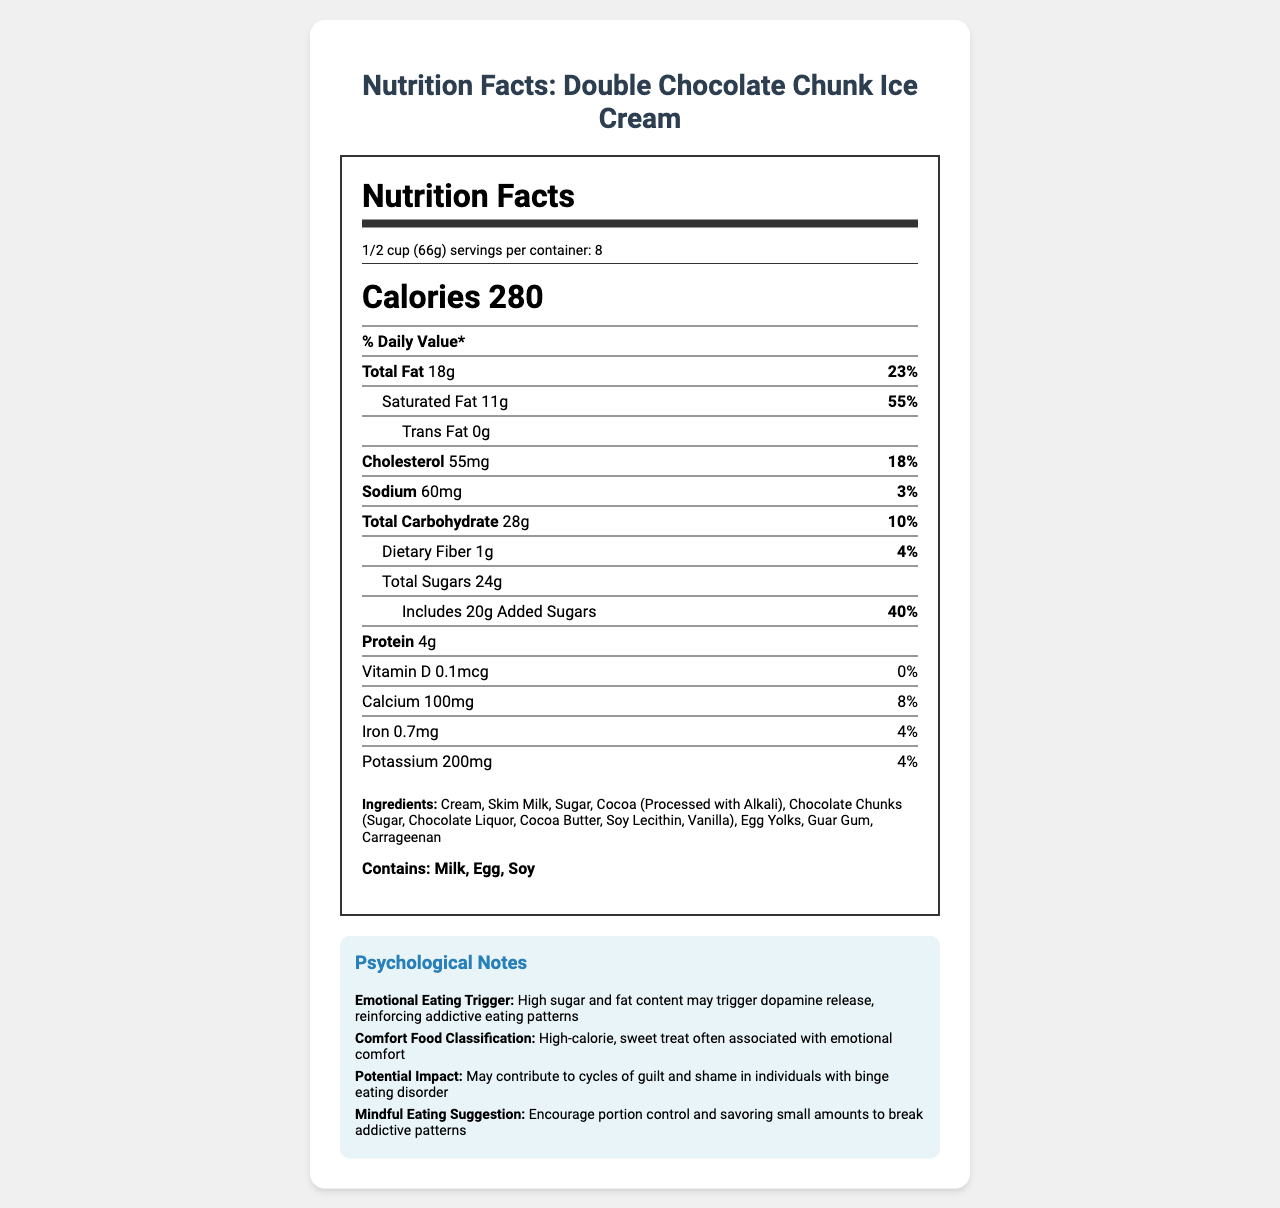what is the serving size? The serving size is listed at the beginning of the nutrition label as "1/2 cup (66g)."
Answer: 1/2 cup (66g) How many calories are there per serving? The calories per serving are stated as 280 in the calories section.
Answer: 280 What is the total fat daily value percentage? The total fat daily value percentage is listed as 23% next to the total fat amount.
Answer: 23% How much sugar is added to the ice cream per serving? The added sugars amount is provided as 20g in the total sugars section.
Answer: 20g Does this product contain trans fat? The trans fat amount is shown as 0g, indicating that there is no trans fat in the product.
Answer: No How many grams of protein are in one serving? The amount of protein per serving is listed as 4g under the protein section.
Answer: 4g Which of the following is a main ingredient in the ice cream? A. High-Fructose Corn Syrup B. Sugar C. Corn Starch D. Artificial Flavors Sugar is listed under the ingredients section, while the other ingredients are not mentioned.
Answer: B What percentage of the daily value of saturated fat does one serving of this ice cream provide? A. 25% B. 40% C. 55% D. 70% The saturated fat daily value percentage is shown as 55% next to the saturated fat amount.
Answer: C Does the ice cream contain any allergens? The allergen section mentions Milk, Egg, and Soy.
Answer: Yes How would you summarize the psychological notes on this document? The psychological notes describe how the ice cream's high sugar and fat content can trigger dopamine release, reinforcing addictive eating patterns and leading to feelings of guilt and shame, especially in people with binge eating disorder.
Answer: Comfort food with high sugar and fat content that can trigger emotional eating and addictive behavior, potentially leading to guilt and shame cycles. What is the level of vitamin D in one serving of this ice cream? The amount of vitamin D per serving is given as 0.1mcg under the vitamin D section.
Answer: 0.1mcg What is the potential impact of this product on someone with binge eating disorder? The psychological notes mention that this product may contribute to cycles of guilt and shame in individuals with binge eating disorder.
Answer: May contribute to cycles of guilt and shame. What mindful eating suggestion is provided? The psychological notes suggest encouraging portion control and savoring small amounts to break addictive eating patterns.
Answer: Encourage portion control and savoring small amounts to break addictive patterns. What % daily value of sodium does one serving of this product provide? The sodium daily value percentage is listed as 3% next to the sodium amount.
Answer: 3% Does the product contain guar gum? Guar gum is listed among the ingredients.
Answer: Yes What is the total carbohydrate amount per serving? The total carbohydrate amount is listed as 28g in the total carbohydrate section.
Answer: 28g Is the main ingredient of this product chocolate? The main ingredient is cream, as listed first among the ingredients.
Answer: No What is the expiry date of the product? The document does not provide any information regarding the expiry date of the product.
Answer: Cannot be determined 